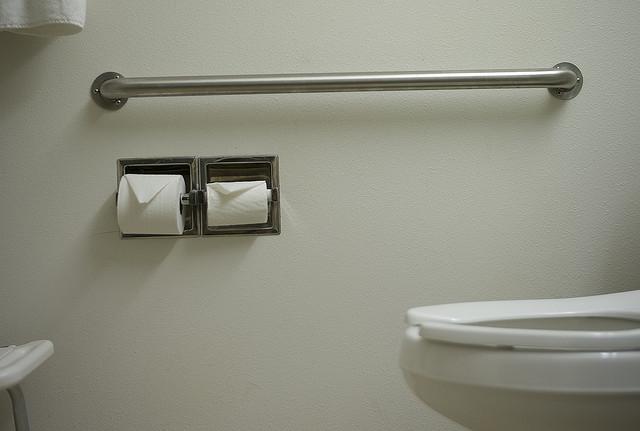What is the bar for?
Give a very brief answer. Towels. Are there more than two rolls of tp?
Quick response, please. No. How many rolls of toilet paper are there?
Quick response, please. 2. 